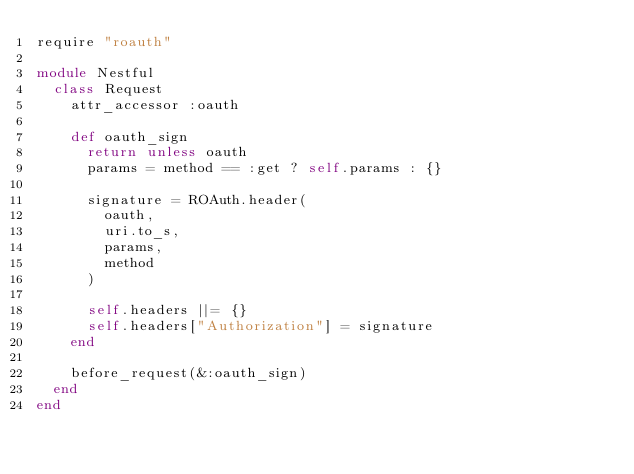Convert code to text. <code><loc_0><loc_0><loc_500><loc_500><_Ruby_>require "roauth"

module Nestful
  class Request
    attr_accessor :oauth
    
    def oauth_sign
      return unless oauth
      params = method == :get ? self.params : {}

      signature = ROAuth.header(
        oauth, 
        uri.to_s, 
        params, 
        method
      )
    
      self.headers ||= {}
      self.headers["Authorization"] = signature
    end

    before_request(&:oauth_sign)
  end
end</code> 